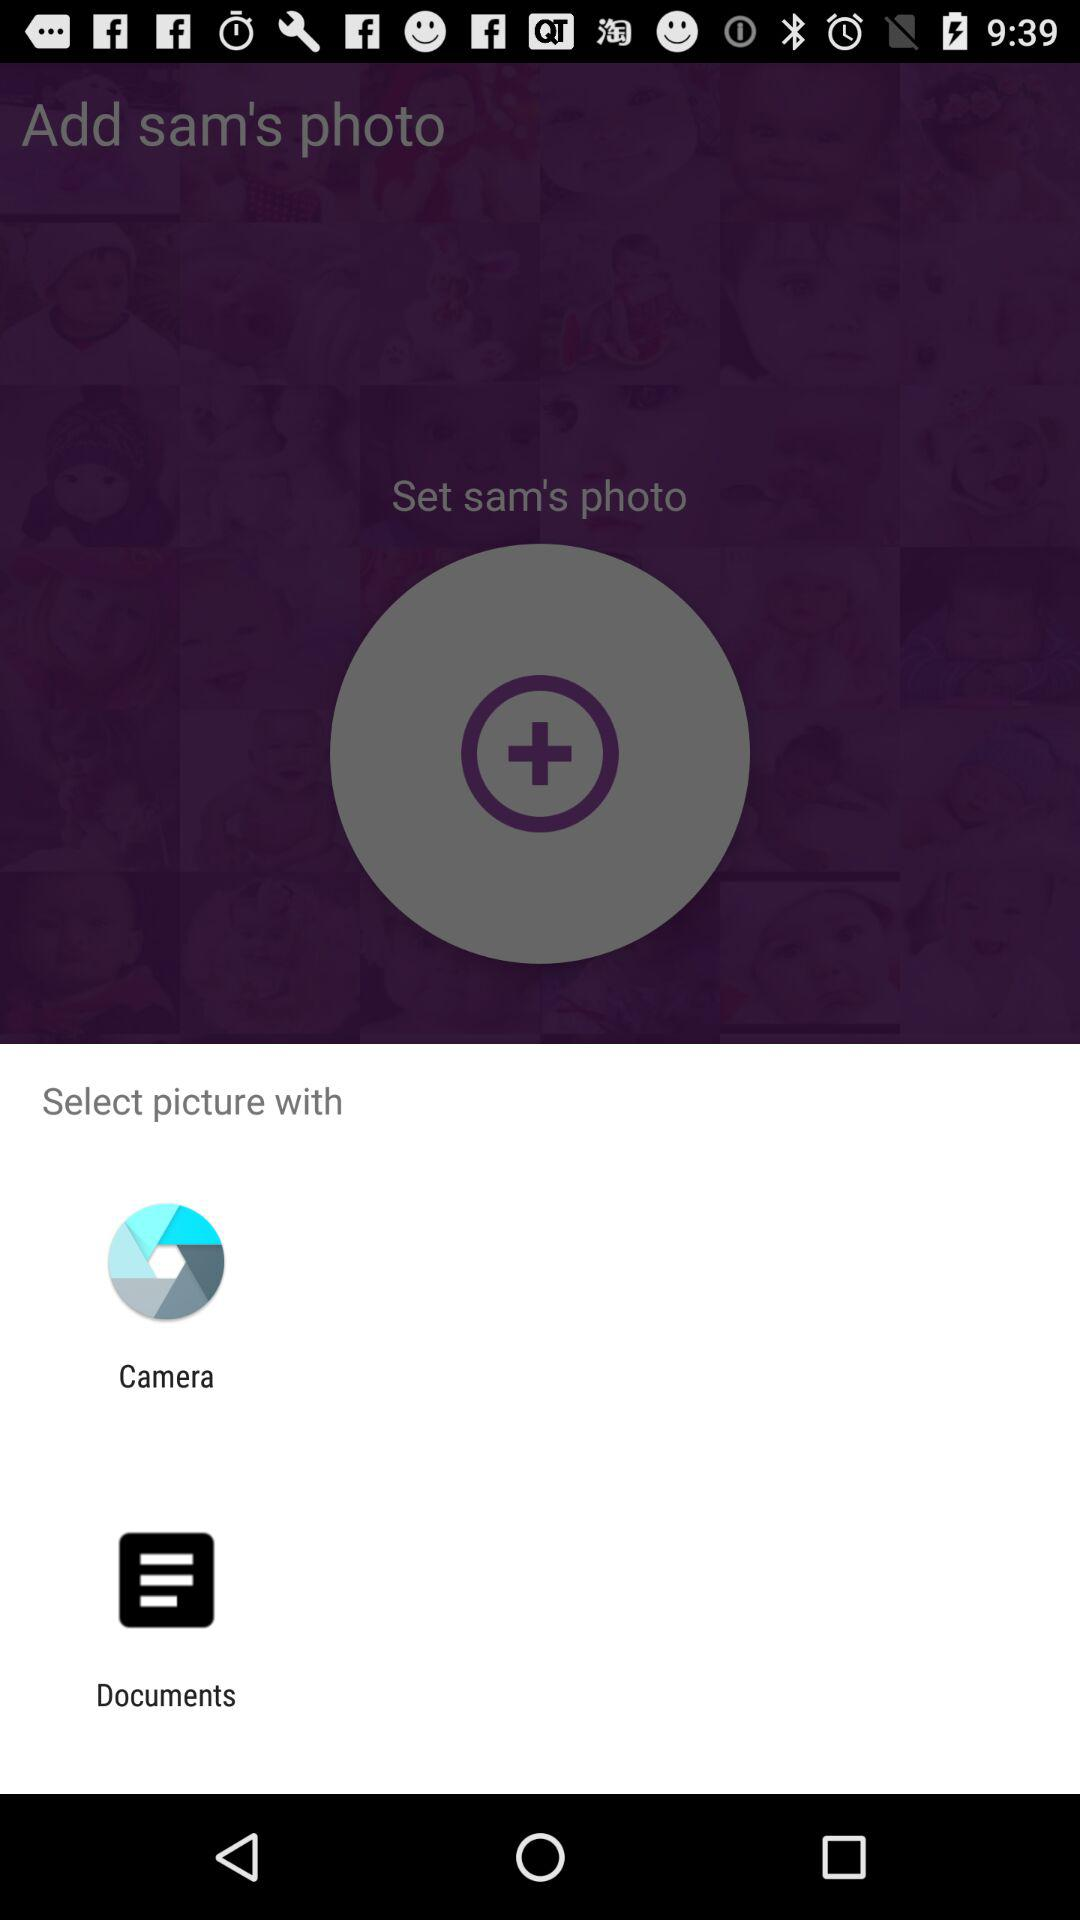Through what app can I select a picture? You can select a picture with the "Camera" app. 